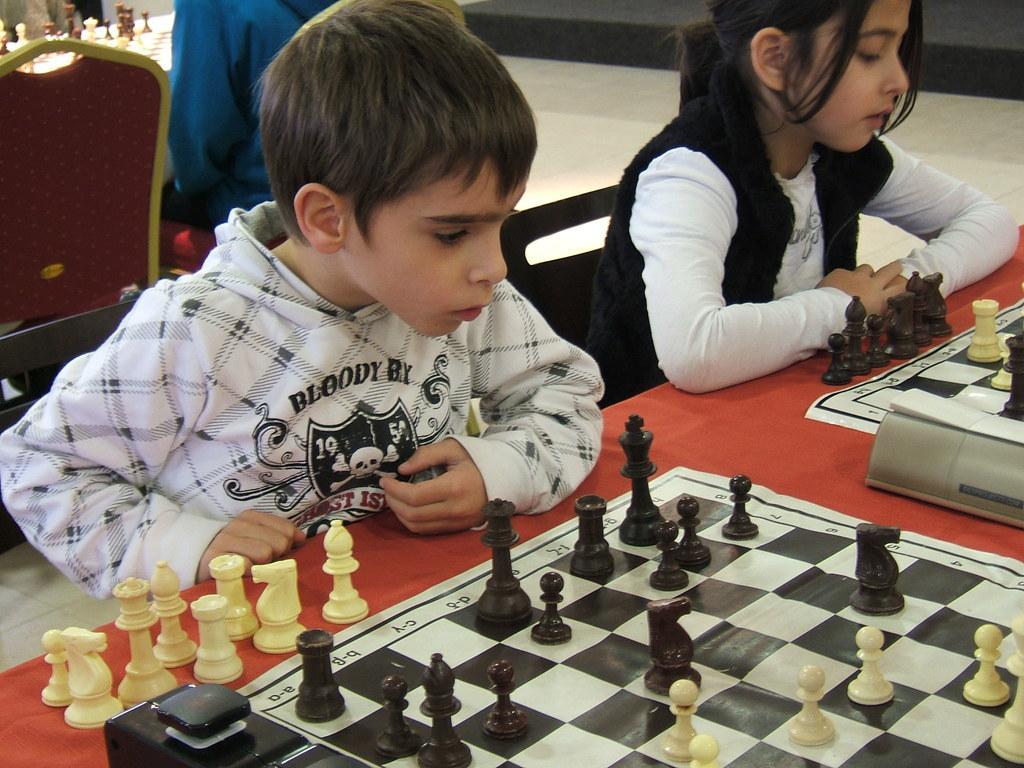Can you describe this image briefly? This picture is of inside the room. In the center there is a red color table on the top of which two chess boards are placed and there is a boy and a girl sitting on the chair. In the background we can see the other table on the top of which a chess board is placed and there is a man sitting on the chair and a red color chair. 